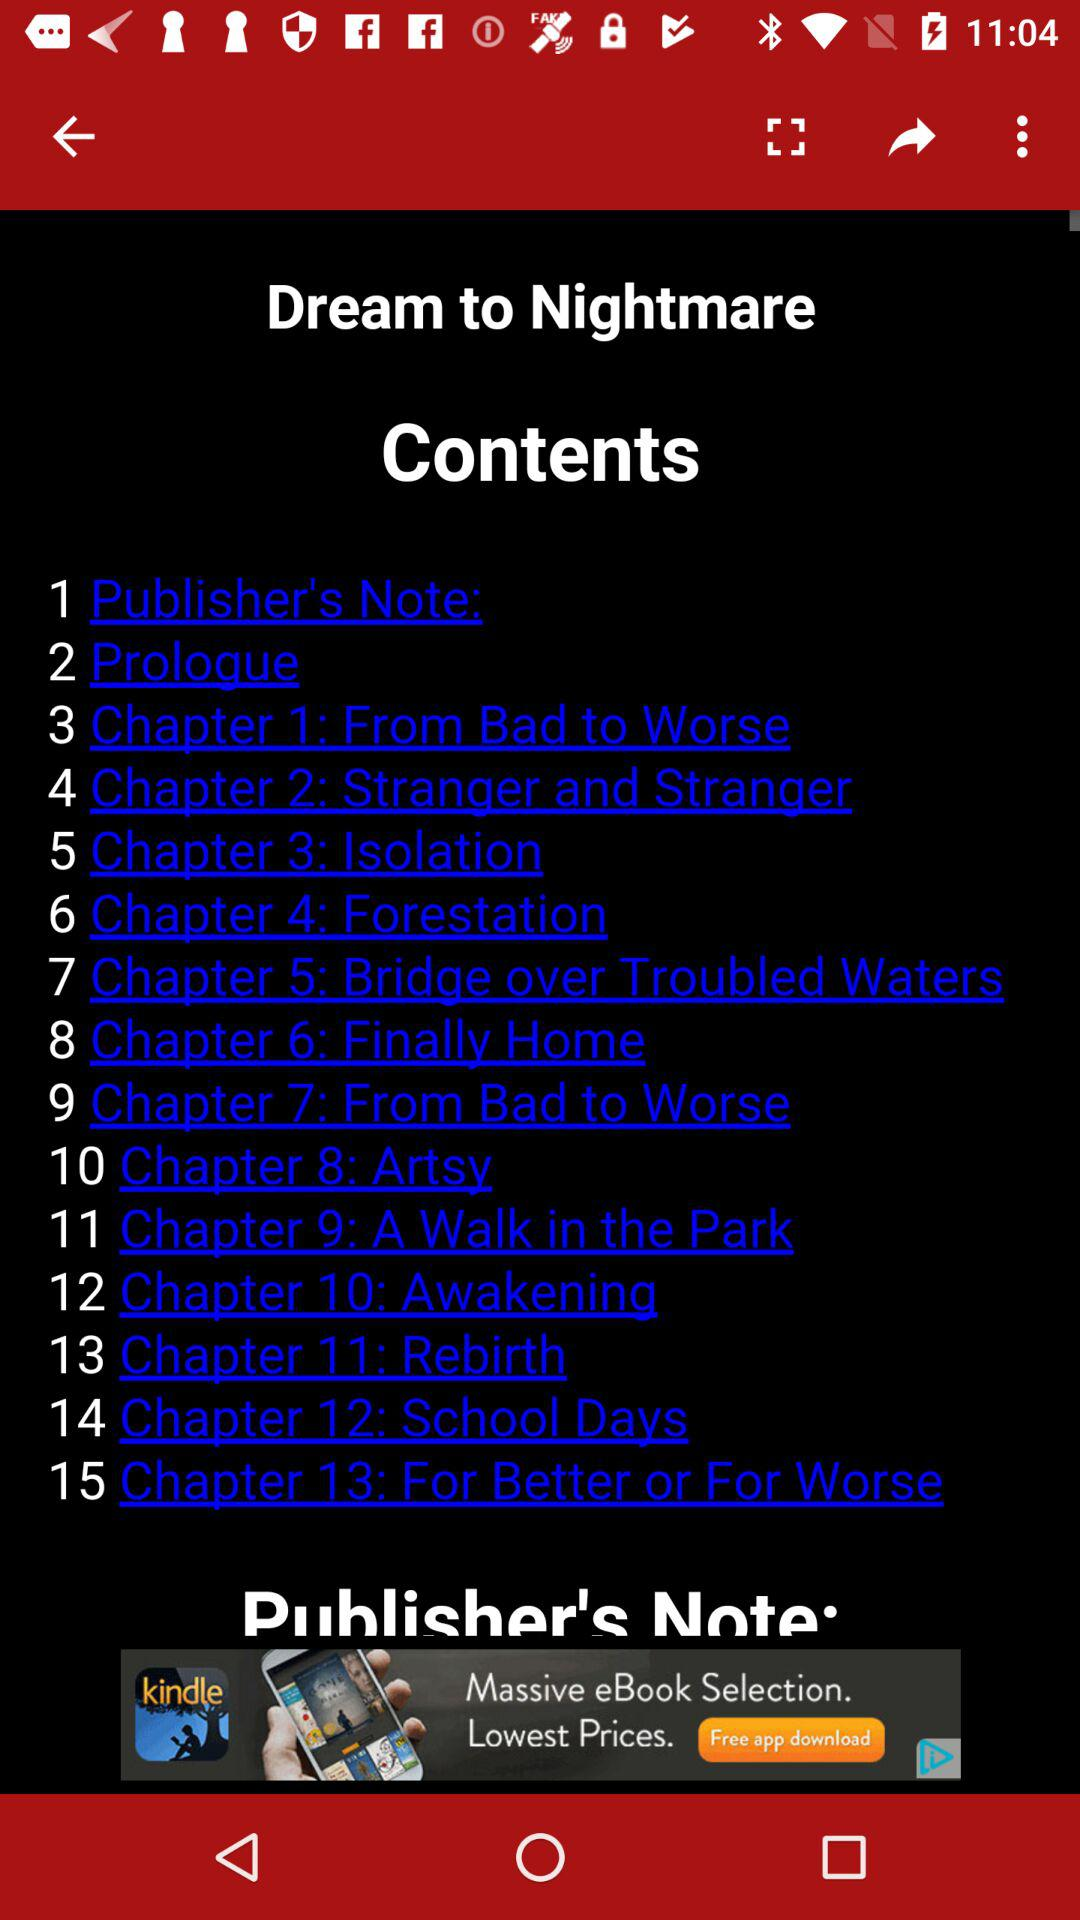Which chapter number is "Isolation"? The chapter number of "Isolation" is 3. 